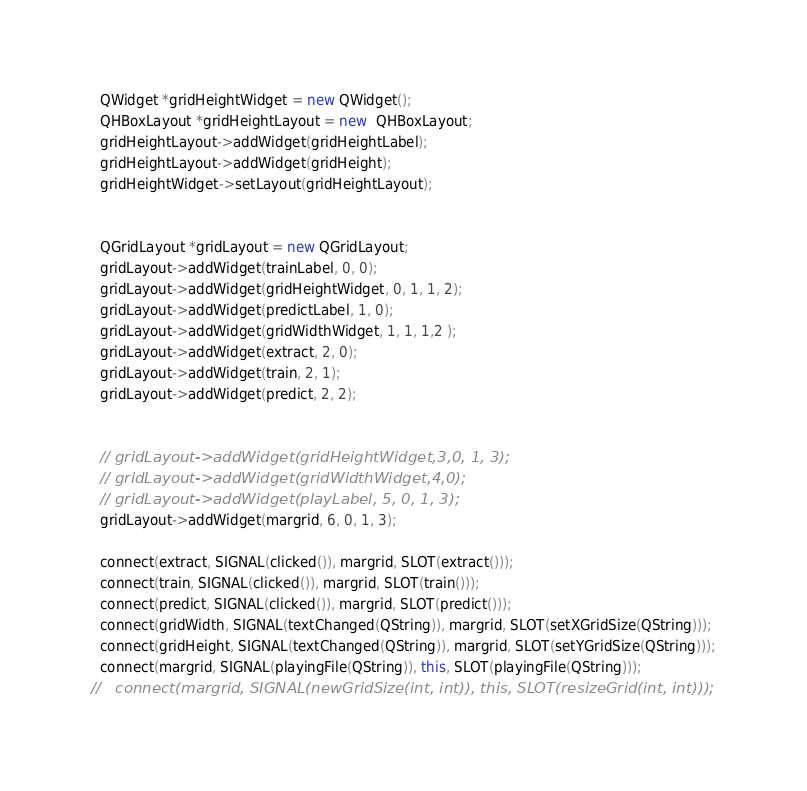<code> <loc_0><loc_0><loc_500><loc_500><_C++_>
  QWidget *gridHeightWidget = new QWidget();
  QHBoxLayout *gridHeightLayout = new  QHBoxLayout;
  gridHeightLayout->addWidget(gridHeightLabel);
  gridHeightLayout->addWidget(gridHeight);
  gridHeightWidget->setLayout(gridHeightLayout);


  QGridLayout *gridLayout = new QGridLayout;
  gridLayout->addWidget(trainLabel, 0, 0);
  gridLayout->addWidget(gridHeightWidget, 0, 1, 1, 2);
  gridLayout->addWidget(predictLabel, 1, 0);
  gridLayout->addWidget(gridWidthWidget, 1, 1, 1,2 );
  gridLayout->addWidget(extract, 2, 0);
  gridLayout->addWidget(train, 2, 1);
  gridLayout->addWidget(predict, 2, 2);


  // gridLayout->addWidget(gridHeightWidget,3,0, 1, 3);
  // gridLayout->addWidget(gridWidthWidget,4,0);
  // gridLayout->addWidget(playLabel, 5, 0, 1, 3);
  gridLayout->addWidget(margrid, 6, 0, 1, 3);

  connect(extract, SIGNAL(clicked()), margrid, SLOT(extract()));
  connect(train, SIGNAL(clicked()), margrid, SLOT(train()));
  connect(predict, SIGNAL(clicked()), margrid, SLOT(predict()));
  connect(gridWidth, SIGNAL(textChanged(QString)), margrid, SLOT(setXGridSize(QString)));
  connect(gridHeight, SIGNAL(textChanged(QString)), margrid, SLOT(setYGridSize(QString)));
  connect(margrid, SIGNAL(playingFile(QString)), this, SLOT(playingFile(QString)));
//   connect(margrid, SIGNAL(newGridSize(int, int)), this, SLOT(resizeGrid(int, int)));
</code> 